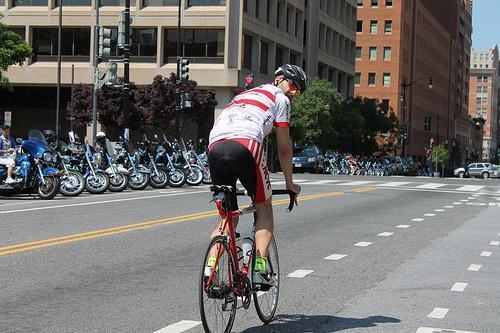How many human-powered bikes are in this picture?
Give a very brief answer. 1. 